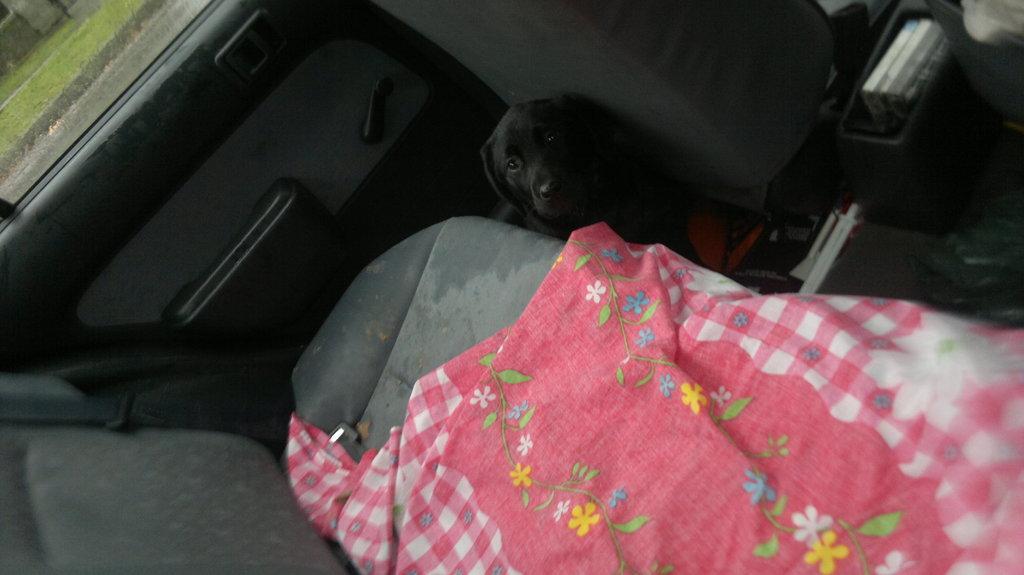Please provide a concise description of this image. This image is taken from inside the car. In this image there is a dog and bed-sheet on the seat, handles and glass window on the door. From the glass window we can see there is a grass. 